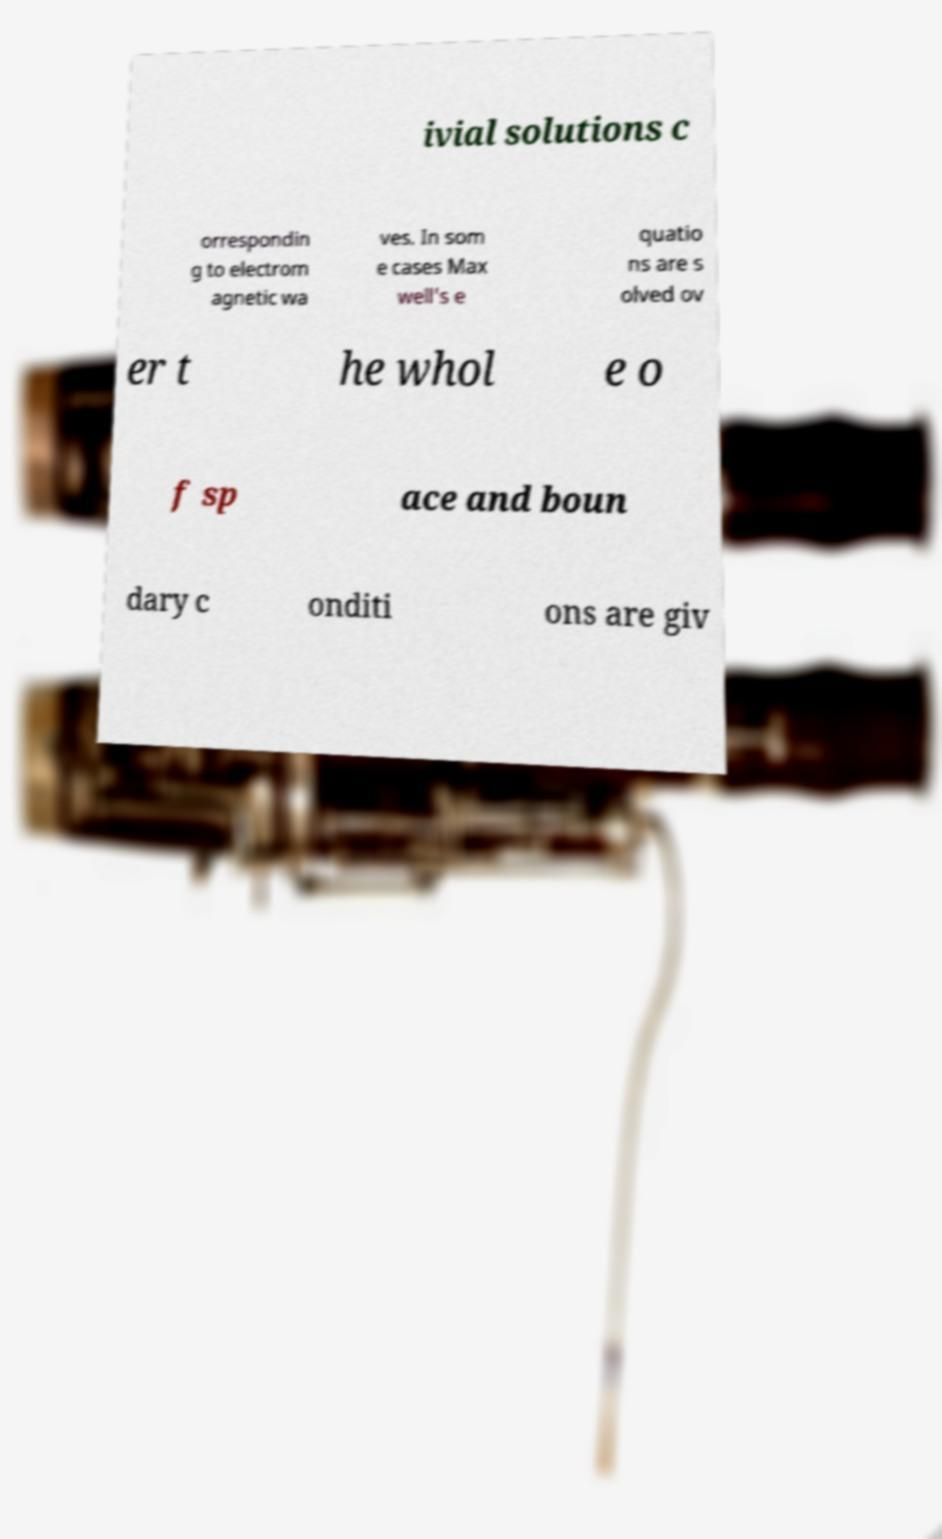Can you accurately transcribe the text from the provided image for me? ivial solutions c orrespondin g to electrom agnetic wa ves. In som e cases Max well's e quatio ns are s olved ov er t he whol e o f sp ace and boun dary c onditi ons are giv 